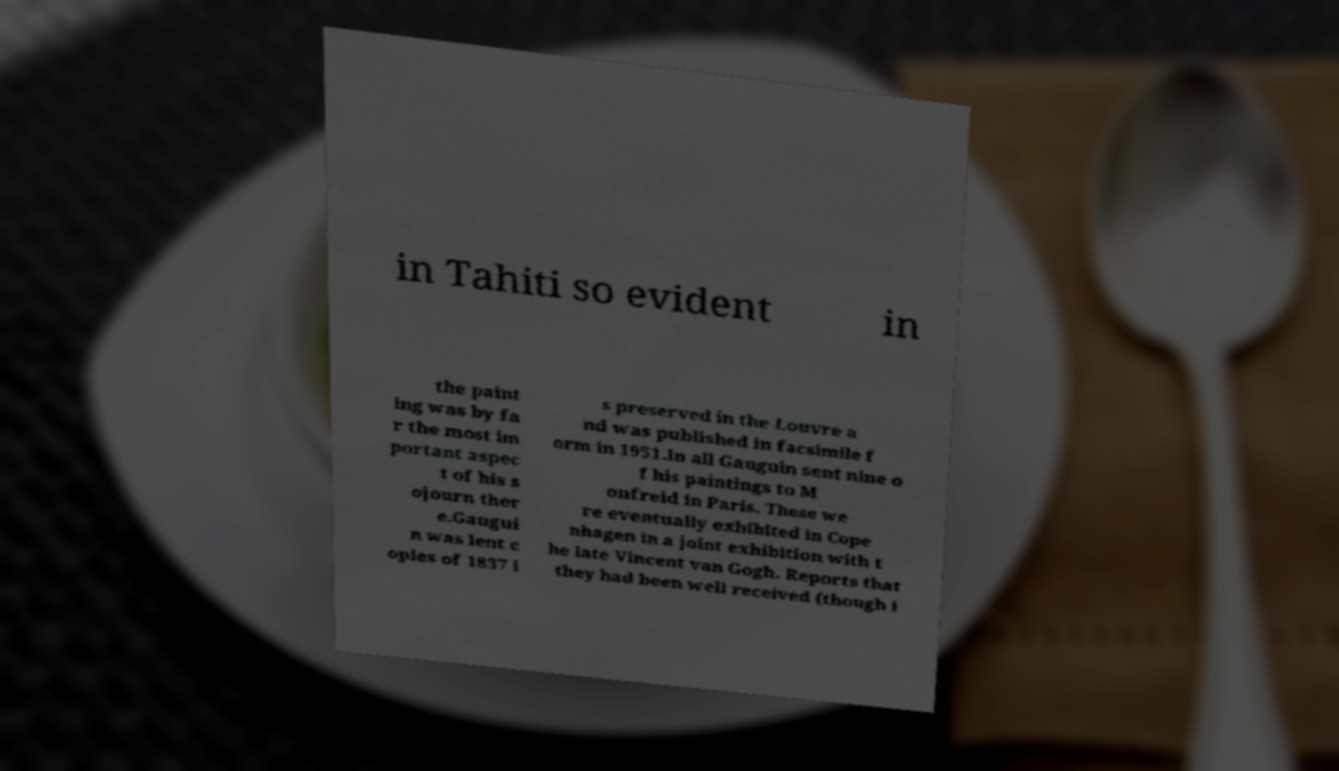Please identify and transcribe the text found in this image. in Tahiti so evident in the paint ing was by fa r the most im portant aspec t of his s ojourn ther e.Gaugui n was lent c opies of 1837 i s preserved in the Louvre a nd was published in facsimile f orm in 1951.In all Gauguin sent nine o f his paintings to M onfreid in Paris. These we re eventually exhibited in Cope nhagen in a joint exhibition with t he late Vincent van Gogh. Reports that they had been well received (though i 